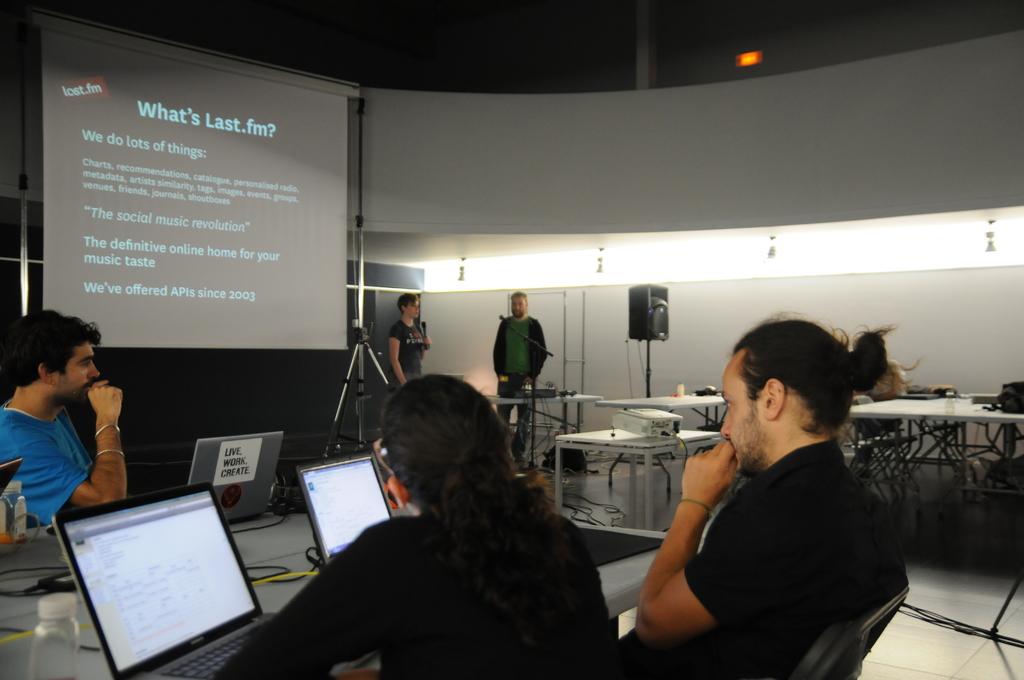When did last.fm begin offering apis?
Provide a short and direct response. 2003. What is the title of the slide?
Keep it short and to the point. What's last.fm?. 